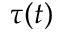<formula> <loc_0><loc_0><loc_500><loc_500>\tau ( t )</formula> 